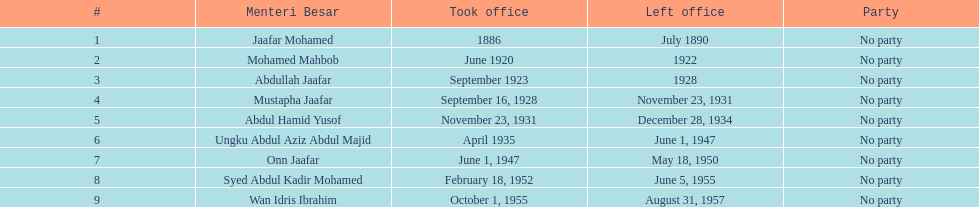Which menteri besars took office in the 1920's? Mohamed Mahbob, Abdullah Jaafar, Mustapha Jaafar. Of those men, who was only in office for 2 years? Mohamed Mahbob. 